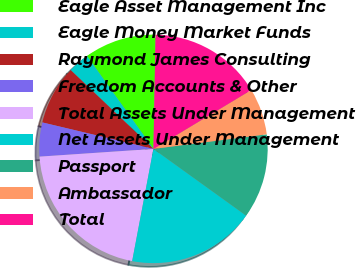Convert chart. <chart><loc_0><loc_0><loc_500><loc_500><pie_chart><fcel>Eagle Asset Management Inc<fcel>Eagle Money Market Funds<fcel>Raymond James Consulting<fcel>Freedom Accounts & Other<fcel>Total Assets Under Management<fcel>Net Assets Under Management<fcel>Passport<fcel>Ambassador<fcel>Total<nl><fcel>10.18%<fcel>3.01%<fcel>8.39%<fcel>4.8%<fcel>20.94%<fcel>18.05%<fcel>11.97%<fcel>6.59%<fcel>16.07%<nl></chart> 